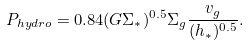<formula> <loc_0><loc_0><loc_500><loc_500>P _ { h y d r o } = 0 . 8 4 ( G \Sigma _ { * } ) ^ { 0 . 5 } \Sigma _ { g } \frac { v _ { g } } { ( h _ { * } ) ^ { 0 . 5 } } . \</formula> 